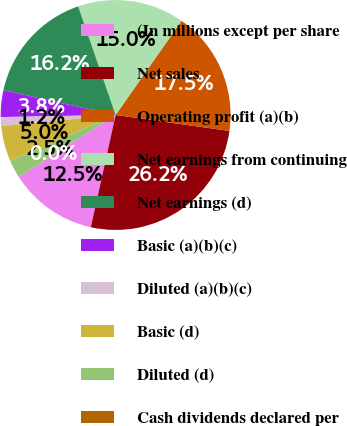Convert chart. <chart><loc_0><loc_0><loc_500><loc_500><pie_chart><fcel>(In millions except per share<fcel>Net sales<fcel>Operating profit (a)(b)<fcel>Net earnings from continuing<fcel>Net earnings (d)<fcel>Basic (a)(b)(c)<fcel>Diluted (a)(b)(c)<fcel>Basic (d)<fcel>Diluted (d)<fcel>Cash dividends declared per<nl><fcel>12.5%<fcel>26.25%<fcel>17.5%<fcel>15.0%<fcel>16.25%<fcel>3.75%<fcel>1.25%<fcel>5.0%<fcel>2.5%<fcel>0.0%<nl></chart> 